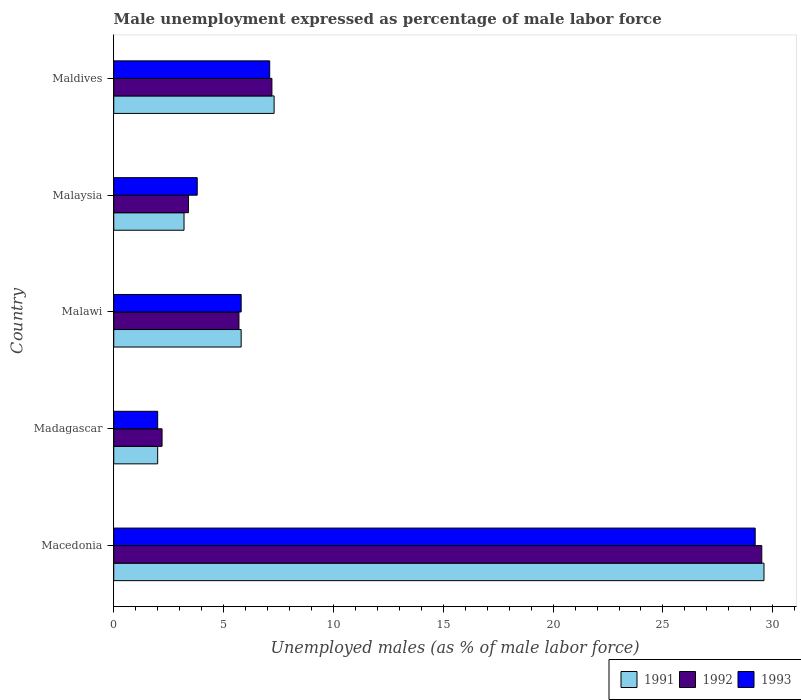How many different coloured bars are there?
Provide a succinct answer. 3. How many groups of bars are there?
Your answer should be compact. 5. Are the number of bars per tick equal to the number of legend labels?
Make the answer very short. Yes. How many bars are there on the 5th tick from the top?
Offer a very short reply. 3. How many bars are there on the 2nd tick from the bottom?
Give a very brief answer. 3. What is the label of the 4th group of bars from the top?
Provide a succinct answer. Madagascar. What is the unemployment in males in in 1993 in Malawi?
Ensure brevity in your answer.  5.8. Across all countries, what is the maximum unemployment in males in in 1992?
Offer a very short reply. 29.5. In which country was the unemployment in males in in 1992 maximum?
Ensure brevity in your answer.  Macedonia. In which country was the unemployment in males in in 1991 minimum?
Provide a short and direct response. Madagascar. What is the total unemployment in males in in 1993 in the graph?
Make the answer very short. 47.9. What is the difference between the unemployment in males in in 1991 in Macedonia and that in Maldives?
Your response must be concise. 22.3. What is the difference between the unemployment in males in in 1993 in Malaysia and the unemployment in males in in 1992 in Macedonia?
Your response must be concise. -25.7. What is the average unemployment in males in in 1992 per country?
Provide a succinct answer. 9.6. What is the difference between the unemployment in males in in 1992 and unemployment in males in in 1993 in Malawi?
Provide a short and direct response. -0.1. In how many countries, is the unemployment in males in in 1993 greater than 18 %?
Offer a very short reply. 1. What is the ratio of the unemployment in males in in 1992 in Madagascar to that in Malawi?
Provide a succinct answer. 0.39. Is the difference between the unemployment in males in in 1992 in Malawi and Malaysia greater than the difference between the unemployment in males in in 1993 in Malawi and Malaysia?
Ensure brevity in your answer.  Yes. What is the difference between the highest and the second highest unemployment in males in in 1993?
Your response must be concise. 22.1. What is the difference between the highest and the lowest unemployment in males in in 1992?
Your response must be concise. 27.3. In how many countries, is the unemployment in males in in 1991 greater than the average unemployment in males in in 1991 taken over all countries?
Make the answer very short. 1. Is the sum of the unemployment in males in in 1992 in Madagascar and Maldives greater than the maximum unemployment in males in in 1993 across all countries?
Give a very brief answer. No. What does the 3rd bar from the bottom in Malawi represents?
Make the answer very short. 1993. Is it the case that in every country, the sum of the unemployment in males in in 1991 and unemployment in males in in 1993 is greater than the unemployment in males in in 1992?
Your answer should be compact. Yes. How many bars are there?
Keep it short and to the point. 15. How many countries are there in the graph?
Your answer should be very brief. 5. What is the difference between two consecutive major ticks on the X-axis?
Your answer should be compact. 5. Where does the legend appear in the graph?
Your response must be concise. Bottom right. What is the title of the graph?
Give a very brief answer. Male unemployment expressed as percentage of male labor force. Does "1995" appear as one of the legend labels in the graph?
Give a very brief answer. No. What is the label or title of the X-axis?
Provide a short and direct response. Unemployed males (as % of male labor force). What is the Unemployed males (as % of male labor force) in 1991 in Macedonia?
Your response must be concise. 29.6. What is the Unemployed males (as % of male labor force) in 1992 in Macedonia?
Your answer should be compact. 29.5. What is the Unemployed males (as % of male labor force) of 1993 in Macedonia?
Offer a terse response. 29.2. What is the Unemployed males (as % of male labor force) in 1992 in Madagascar?
Keep it short and to the point. 2.2. What is the Unemployed males (as % of male labor force) of 1993 in Madagascar?
Offer a very short reply. 2. What is the Unemployed males (as % of male labor force) of 1991 in Malawi?
Your answer should be compact. 5.8. What is the Unemployed males (as % of male labor force) of 1992 in Malawi?
Your answer should be compact. 5.7. What is the Unemployed males (as % of male labor force) of 1993 in Malawi?
Your answer should be compact. 5.8. What is the Unemployed males (as % of male labor force) in 1991 in Malaysia?
Your response must be concise. 3.2. What is the Unemployed males (as % of male labor force) in 1992 in Malaysia?
Your answer should be very brief. 3.4. What is the Unemployed males (as % of male labor force) of 1993 in Malaysia?
Your answer should be very brief. 3.8. What is the Unemployed males (as % of male labor force) in 1991 in Maldives?
Ensure brevity in your answer.  7.3. What is the Unemployed males (as % of male labor force) in 1992 in Maldives?
Your response must be concise. 7.2. What is the Unemployed males (as % of male labor force) in 1993 in Maldives?
Your answer should be very brief. 7.1. Across all countries, what is the maximum Unemployed males (as % of male labor force) of 1991?
Your answer should be compact. 29.6. Across all countries, what is the maximum Unemployed males (as % of male labor force) in 1992?
Provide a succinct answer. 29.5. Across all countries, what is the maximum Unemployed males (as % of male labor force) in 1993?
Provide a succinct answer. 29.2. Across all countries, what is the minimum Unemployed males (as % of male labor force) in 1992?
Your response must be concise. 2.2. Across all countries, what is the minimum Unemployed males (as % of male labor force) in 1993?
Your answer should be very brief. 2. What is the total Unemployed males (as % of male labor force) of 1991 in the graph?
Provide a succinct answer. 47.9. What is the total Unemployed males (as % of male labor force) of 1992 in the graph?
Provide a short and direct response. 48. What is the total Unemployed males (as % of male labor force) of 1993 in the graph?
Provide a succinct answer. 47.9. What is the difference between the Unemployed males (as % of male labor force) in 1991 in Macedonia and that in Madagascar?
Keep it short and to the point. 27.6. What is the difference between the Unemployed males (as % of male labor force) in 1992 in Macedonia and that in Madagascar?
Your response must be concise. 27.3. What is the difference between the Unemployed males (as % of male labor force) of 1993 in Macedonia and that in Madagascar?
Offer a terse response. 27.2. What is the difference between the Unemployed males (as % of male labor force) of 1991 in Macedonia and that in Malawi?
Keep it short and to the point. 23.8. What is the difference between the Unemployed males (as % of male labor force) of 1992 in Macedonia and that in Malawi?
Make the answer very short. 23.8. What is the difference between the Unemployed males (as % of male labor force) of 1993 in Macedonia and that in Malawi?
Provide a short and direct response. 23.4. What is the difference between the Unemployed males (as % of male labor force) of 1991 in Macedonia and that in Malaysia?
Offer a terse response. 26.4. What is the difference between the Unemployed males (as % of male labor force) of 1992 in Macedonia and that in Malaysia?
Provide a short and direct response. 26.1. What is the difference between the Unemployed males (as % of male labor force) in 1993 in Macedonia and that in Malaysia?
Your answer should be very brief. 25.4. What is the difference between the Unemployed males (as % of male labor force) of 1991 in Macedonia and that in Maldives?
Your answer should be compact. 22.3. What is the difference between the Unemployed males (as % of male labor force) of 1992 in Macedonia and that in Maldives?
Provide a succinct answer. 22.3. What is the difference between the Unemployed males (as % of male labor force) of 1993 in Macedonia and that in Maldives?
Keep it short and to the point. 22.1. What is the difference between the Unemployed males (as % of male labor force) of 1992 in Madagascar and that in Malawi?
Your answer should be very brief. -3.5. What is the difference between the Unemployed males (as % of male labor force) of 1993 in Madagascar and that in Malawi?
Provide a short and direct response. -3.8. What is the difference between the Unemployed males (as % of male labor force) of 1991 in Madagascar and that in Malaysia?
Provide a short and direct response. -1.2. What is the difference between the Unemployed males (as % of male labor force) of 1992 in Madagascar and that in Malaysia?
Your response must be concise. -1.2. What is the difference between the Unemployed males (as % of male labor force) in 1991 in Malawi and that in Maldives?
Provide a short and direct response. -1.5. What is the difference between the Unemployed males (as % of male labor force) of 1992 in Malawi and that in Maldives?
Your response must be concise. -1.5. What is the difference between the Unemployed males (as % of male labor force) in 1993 in Malaysia and that in Maldives?
Keep it short and to the point. -3.3. What is the difference between the Unemployed males (as % of male labor force) of 1991 in Macedonia and the Unemployed males (as % of male labor force) of 1992 in Madagascar?
Keep it short and to the point. 27.4. What is the difference between the Unemployed males (as % of male labor force) in 1991 in Macedonia and the Unemployed males (as % of male labor force) in 1993 in Madagascar?
Provide a succinct answer. 27.6. What is the difference between the Unemployed males (as % of male labor force) of 1991 in Macedonia and the Unemployed males (as % of male labor force) of 1992 in Malawi?
Your response must be concise. 23.9. What is the difference between the Unemployed males (as % of male labor force) of 1991 in Macedonia and the Unemployed males (as % of male labor force) of 1993 in Malawi?
Keep it short and to the point. 23.8. What is the difference between the Unemployed males (as % of male labor force) in 1992 in Macedonia and the Unemployed males (as % of male labor force) in 1993 in Malawi?
Provide a succinct answer. 23.7. What is the difference between the Unemployed males (as % of male labor force) in 1991 in Macedonia and the Unemployed males (as % of male labor force) in 1992 in Malaysia?
Keep it short and to the point. 26.2. What is the difference between the Unemployed males (as % of male labor force) of 1991 in Macedonia and the Unemployed males (as % of male labor force) of 1993 in Malaysia?
Offer a terse response. 25.8. What is the difference between the Unemployed males (as % of male labor force) of 1992 in Macedonia and the Unemployed males (as % of male labor force) of 1993 in Malaysia?
Make the answer very short. 25.7. What is the difference between the Unemployed males (as % of male labor force) in 1991 in Macedonia and the Unemployed males (as % of male labor force) in 1992 in Maldives?
Offer a very short reply. 22.4. What is the difference between the Unemployed males (as % of male labor force) of 1991 in Macedonia and the Unemployed males (as % of male labor force) of 1993 in Maldives?
Provide a short and direct response. 22.5. What is the difference between the Unemployed males (as % of male labor force) in 1992 in Macedonia and the Unemployed males (as % of male labor force) in 1993 in Maldives?
Give a very brief answer. 22.4. What is the difference between the Unemployed males (as % of male labor force) in 1991 in Madagascar and the Unemployed males (as % of male labor force) in 1992 in Malawi?
Provide a short and direct response. -3.7. What is the difference between the Unemployed males (as % of male labor force) in 1992 in Madagascar and the Unemployed males (as % of male labor force) in 1993 in Malawi?
Keep it short and to the point. -3.6. What is the difference between the Unemployed males (as % of male labor force) of 1991 in Madagascar and the Unemployed males (as % of male labor force) of 1993 in Malaysia?
Your response must be concise. -1.8. What is the difference between the Unemployed males (as % of male labor force) of 1992 in Madagascar and the Unemployed males (as % of male labor force) of 1993 in Malaysia?
Ensure brevity in your answer.  -1.6. What is the difference between the Unemployed males (as % of male labor force) of 1991 in Madagascar and the Unemployed males (as % of male labor force) of 1992 in Maldives?
Offer a very short reply. -5.2. What is the difference between the Unemployed males (as % of male labor force) in 1991 in Madagascar and the Unemployed males (as % of male labor force) in 1993 in Maldives?
Your answer should be compact. -5.1. What is the difference between the Unemployed males (as % of male labor force) in 1991 in Malawi and the Unemployed males (as % of male labor force) in 1992 in Malaysia?
Provide a succinct answer. 2.4. What is the difference between the Unemployed males (as % of male labor force) in 1992 in Malawi and the Unemployed males (as % of male labor force) in 1993 in Malaysia?
Give a very brief answer. 1.9. What is the difference between the Unemployed males (as % of male labor force) in 1992 in Malawi and the Unemployed males (as % of male labor force) in 1993 in Maldives?
Give a very brief answer. -1.4. What is the difference between the Unemployed males (as % of male labor force) of 1991 in Malaysia and the Unemployed males (as % of male labor force) of 1992 in Maldives?
Make the answer very short. -4. What is the difference between the Unemployed males (as % of male labor force) in 1992 in Malaysia and the Unemployed males (as % of male labor force) in 1993 in Maldives?
Offer a terse response. -3.7. What is the average Unemployed males (as % of male labor force) of 1991 per country?
Make the answer very short. 9.58. What is the average Unemployed males (as % of male labor force) in 1993 per country?
Your answer should be compact. 9.58. What is the difference between the Unemployed males (as % of male labor force) of 1991 and Unemployed males (as % of male labor force) of 1993 in Macedonia?
Make the answer very short. 0.4. What is the difference between the Unemployed males (as % of male labor force) in 1991 and Unemployed males (as % of male labor force) in 1993 in Malawi?
Offer a terse response. 0. What is the difference between the Unemployed males (as % of male labor force) of 1991 and Unemployed males (as % of male labor force) of 1993 in Malaysia?
Provide a succinct answer. -0.6. What is the difference between the Unemployed males (as % of male labor force) in 1992 and Unemployed males (as % of male labor force) in 1993 in Maldives?
Your answer should be compact. 0.1. What is the ratio of the Unemployed males (as % of male labor force) in 1992 in Macedonia to that in Madagascar?
Your response must be concise. 13.41. What is the ratio of the Unemployed males (as % of male labor force) of 1993 in Macedonia to that in Madagascar?
Offer a very short reply. 14.6. What is the ratio of the Unemployed males (as % of male labor force) of 1991 in Macedonia to that in Malawi?
Offer a very short reply. 5.1. What is the ratio of the Unemployed males (as % of male labor force) in 1992 in Macedonia to that in Malawi?
Provide a succinct answer. 5.18. What is the ratio of the Unemployed males (as % of male labor force) in 1993 in Macedonia to that in Malawi?
Provide a short and direct response. 5.03. What is the ratio of the Unemployed males (as % of male labor force) of 1991 in Macedonia to that in Malaysia?
Your answer should be very brief. 9.25. What is the ratio of the Unemployed males (as % of male labor force) in 1992 in Macedonia to that in Malaysia?
Keep it short and to the point. 8.68. What is the ratio of the Unemployed males (as % of male labor force) of 1993 in Macedonia to that in Malaysia?
Your answer should be very brief. 7.68. What is the ratio of the Unemployed males (as % of male labor force) of 1991 in Macedonia to that in Maldives?
Your answer should be compact. 4.05. What is the ratio of the Unemployed males (as % of male labor force) in 1992 in Macedonia to that in Maldives?
Keep it short and to the point. 4.1. What is the ratio of the Unemployed males (as % of male labor force) of 1993 in Macedonia to that in Maldives?
Ensure brevity in your answer.  4.11. What is the ratio of the Unemployed males (as % of male labor force) of 1991 in Madagascar to that in Malawi?
Provide a succinct answer. 0.34. What is the ratio of the Unemployed males (as % of male labor force) of 1992 in Madagascar to that in Malawi?
Ensure brevity in your answer.  0.39. What is the ratio of the Unemployed males (as % of male labor force) in 1993 in Madagascar to that in Malawi?
Make the answer very short. 0.34. What is the ratio of the Unemployed males (as % of male labor force) of 1991 in Madagascar to that in Malaysia?
Your response must be concise. 0.62. What is the ratio of the Unemployed males (as % of male labor force) of 1992 in Madagascar to that in Malaysia?
Keep it short and to the point. 0.65. What is the ratio of the Unemployed males (as % of male labor force) of 1993 in Madagascar to that in Malaysia?
Ensure brevity in your answer.  0.53. What is the ratio of the Unemployed males (as % of male labor force) of 1991 in Madagascar to that in Maldives?
Offer a very short reply. 0.27. What is the ratio of the Unemployed males (as % of male labor force) in 1992 in Madagascar to that in Maldives?
Ensure brevity in your answer.  0.31. What is the ratio of the Unemployed males (as % of male labor force) in 1993 in Madagascar to that in Maldives?
Give a very brief answer. 0.28. What is the ratio of the Unemployed males (as % of male labor force) of 1991 in Malawi to that in Malaysia?
Provide a succinct answer. 1.81. What is the ratio of the Unemployed males (as % of male labor force) in 1992 in Malawi to that in Malaysia?
Ensure brevity in your answer.  1.68. What is the ratio of the Unemployed males (as % of male labor force) in 1993 in Malawi to that in Malaysia?
Offer a terse response. 1.53. What is the ratio of the Unemployed males (as % of male labor force) in 1991 in Malawi to that in Maldives?
Offer a very short reply. 0.79. What is the ratio of the Unemployed males (as % of male labor force) in 1992 in Malawi to that in Maldives?
Give a very brief answer. 0.79. What is the ratio of the Unemployed males (as % of male labor force) of 1993 in Malawi to that in Maldives?
Provide a succinct answer. 0.82. What is the ratio of the Unemployed males (as % of male labor force) of 1991 in Malaysia to that in Maldives?
Provide a succinct answer. 0.44. What is the ratio of the Unemployed males (as % of male labor force) in 1992 in Malaysia to that in Maldives?
Make the answer very short. 0.47. What is the ratio of the Unemployed males (as % of male labor force) in 1993 in Malaysia to that in Maldives?
Give a very brief answer. 0.54. What is the difference between the highest and the second highest Unemployed males (as % of male labor force) in 1991?
Offer a terse response. 22.3. What is the difference between the highest and the second highest Unemployed males (as % of male labor force) in 1992?
Provide a succinct answer. 22.3. What is the difference between the highest and the second highest Unemployed males (as % of male labor force) of 1993?
Keep it short and to the point. 22.1. What is the difference between the highest and the lowest Unemployed males (as % of male labor force) of 1991?
Offer a very short reply. 27.6. What is the difference between the highest and the lowest Unemployed males (as % of male labor force) in 1992?
Your answer should be very brief. 27.3. What is the difference between the highest and the lowest Unemployed males (as % of male labor force) of 1993?
Your response must be concise. 27.2. 